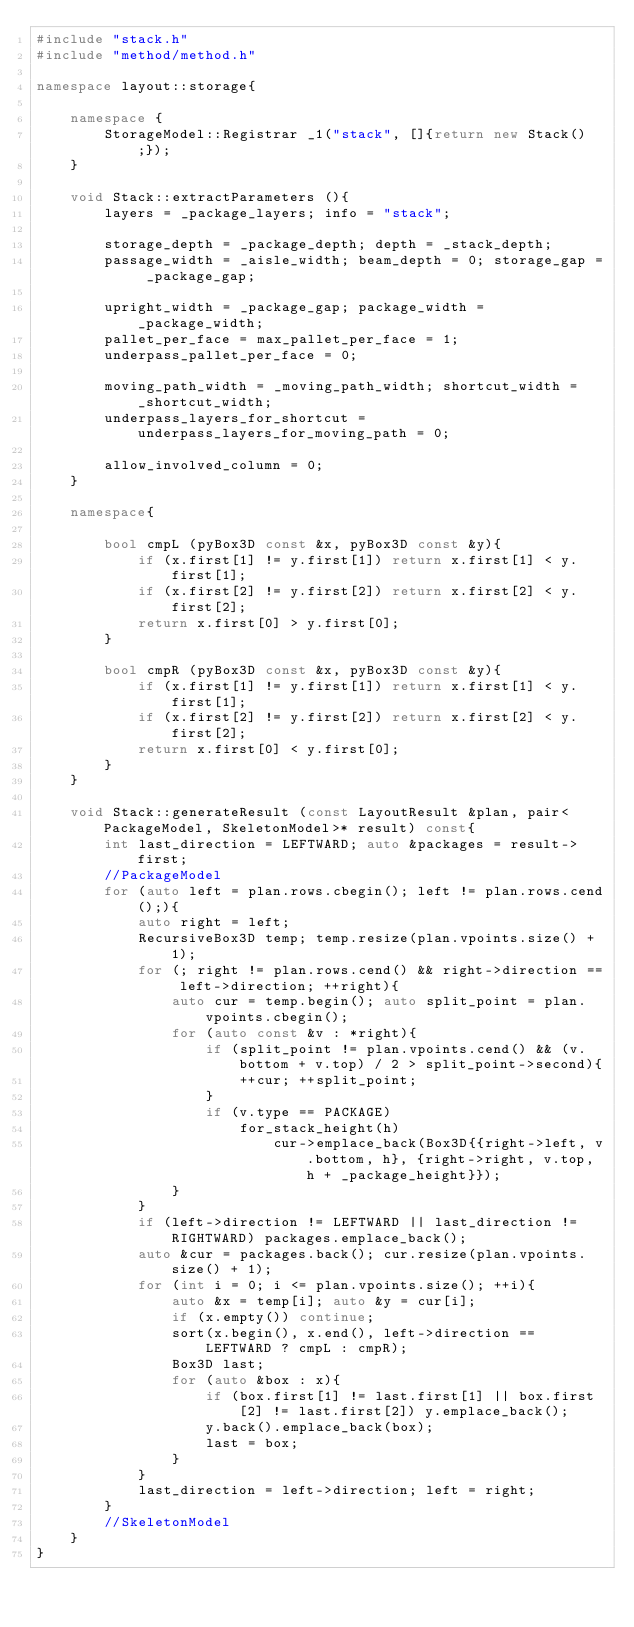Convert code to text. <code><loc_0><loc_0><loc_500><loc_500><_C++_>#include "stack.h"
#include "method/method.h"

namespace layout::storage{

    namespace {
        StorageModel::Registrar _1("stack", []{return new Stack();});
    }

    void Stack::extractParameters (){
        layers = _package_layers; info = "stack";

        storage_depth = _package_depth; depth = _stack_depth;
        passage_width = _aisle_width; beam_depth = 0; storage_gap = _package_gap;

        upright_width = _package_gap; package_width = _package_width;
        pallet_per_face = max_pallet_per_face = 1;
        underpass_pallet_per_face = 0;

        moving_path_width = _moving_path_width; shortcut_width = _shortcut_width;
        underpass_layers_for_shortcut = underpass_layers_for_moving_path = 0;

        allow_involved_column = 0;
    }

    namespace{

        bool cmpL (pyBox3D const &x, pyBox3D const &y){
            if (x.first[1] != y.first[1]) return x.first[1] < y.first[1];
            if (x.first[2] != y.first[2]) return x.first[2] < y.first[2];
            return x.first[0] > y.first[0];
        }

        bool cmpR (pyBox3D const &x, pyBox3D const &y){
            if (x.first[1] != y.first[1]) return x.first[1] < y.first[1];
            if (x.first[2] != y.first[2]) return x.first[2] < y.first[2];
            return x.first[0] < y.first[0];
        }
    }

    void Stack::generateResult (const LayoutResult &plan, pair<PackageModel, SkeletonModel>* result) const{
        int last_direction = LEFTWARD; auto &packages = result->first;
        //PackageModel
        for (auto left = plan.rows.cbegin(); left != plan.rows.cend();){
            auto right = left; 
            RecursiveBox3D temp; temp.resize(plan.vpoints.size() + 1);
            for (; right != plan.rows.cend() && right->direction == left->direction; ++right){
                auto cur = temp.begin(); auto split_point = plan.vpoints.cbegin();
                for (auto const &v : *right){
                    if (split_point != plan.vpoints.cend() && (v.bottom + v.top) / 2 > split_point->second){
                        ++cur; ++split_point;
                    }
                    if (v.type == PACKAGE)
                        for_stack_height(h)
                            cur->emplace_back(Box3D{{right->left, v.bottom, h}, {right->right, v.top, h + _package_height}});
                }
            }
            if (left->direction != LEFTWARD || last_direction != RIGHTWARD) packages.emplace_back();
            auto &cur = packages.back(); cur.resize(plan.vpoints.size() + 1);
            for (int i = 0; i <= plan.vpoints.size(); ++i){
                auto &x = temp[i]; auto &y = cur[i];
                if (x.empty()) continue;
                sort(x.begin(), x.end(), left->direction == LEFTWARD ? cmpL : cmpR);
                Box3D last;
                for (auto &box : x){
                    if (box.first[1] != last.first[1] || box.first[2] != last.first[2]) y.emplace_back();
                    y.back().emplace_back(box);
                    last = box;
                }
            }
            last_direction = left->direction; left = right;
        }
        //SkeletonModel
    }
}

</code> 